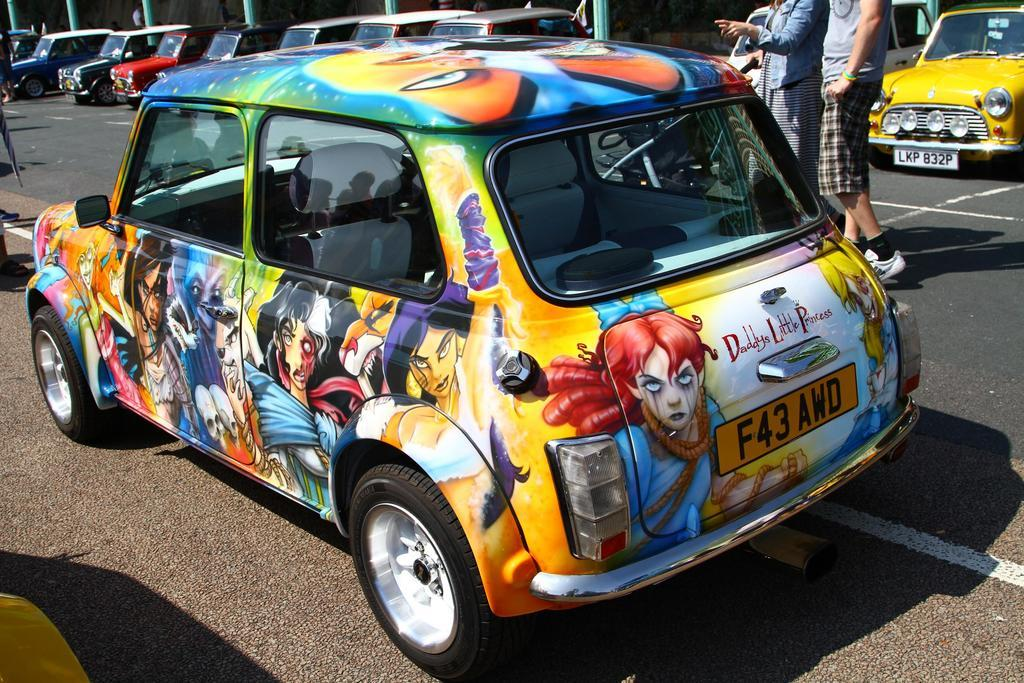What type of car is featured in the image? There is a graffiti car in the image. Where is the car located? The car is on the road. What else can be seen in the background of the image? There are two persons walking in the background of the image. What else is present on the road? There are parked cars on the road. What structures are visible in the image? Poles are visible in the image. How many ladybugs can be seen crawling on the graffiti car in the image? There are no ladybugs present on the graffiti car in the image. What type of vein is visible on the car's windshield? There are no veins visible on the car's windshield in the image. 